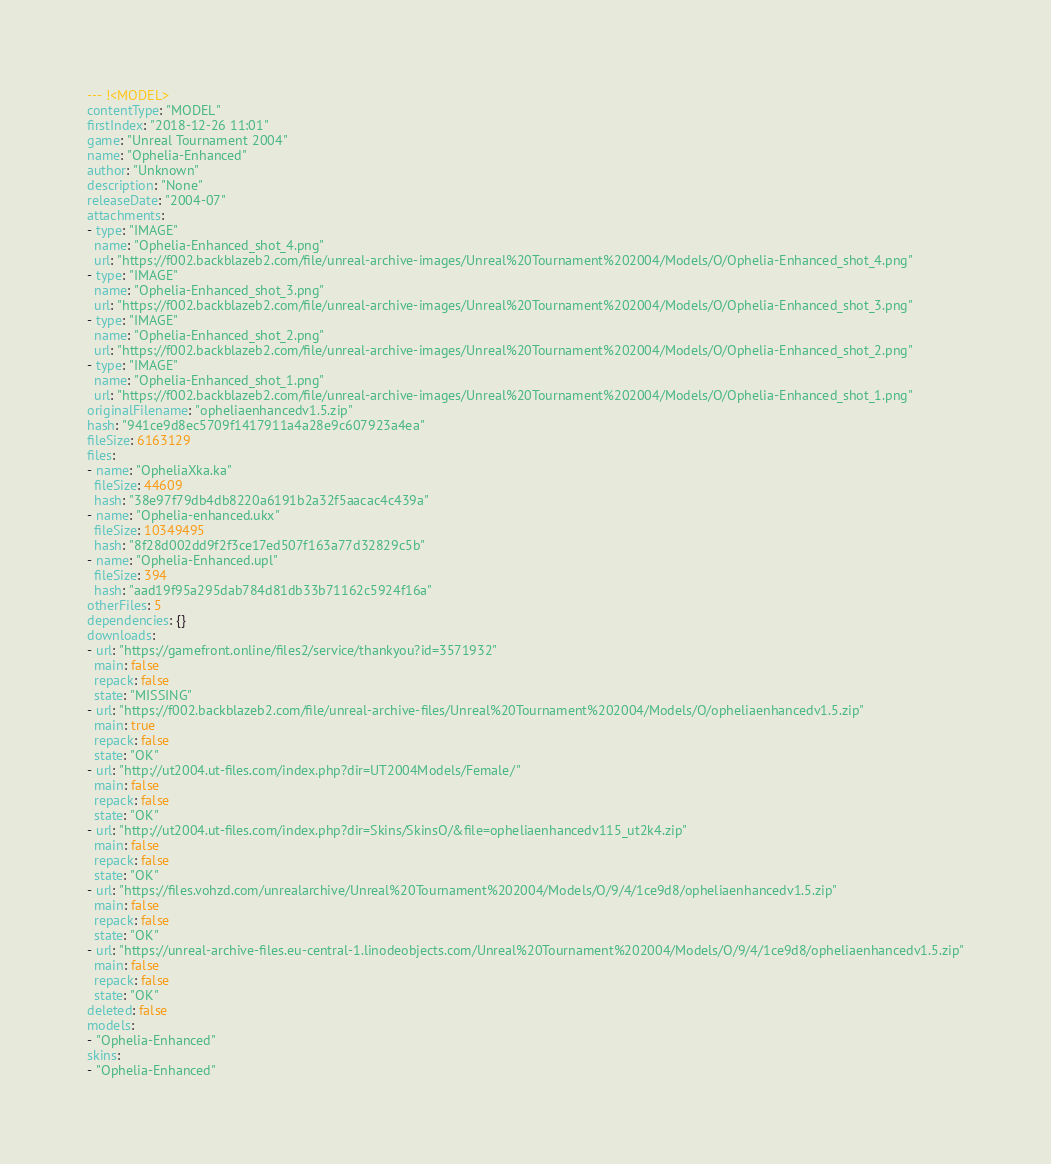Convert code to text. <code><loc_0><loc_0><loc_500><loc_500><_YAML_>--- !<MODEL>
contentType: "MODEL"
firstIndex: "2018-12-26 11:01"
game: "Unreal Tournament 2004"
name: "Ophelia-Enhanced"
author: "Unknown"
description: "None"
releaseDate: "2004-07"
attachments:
- type: "IMAGE"
  name: "Ophelia-Enhanced_shot_4.png"
  url: "https://f002.backblazeb2.com/file/unreal-archive-images/Unreal%20Tournament%202004/Models/O/Ophelia-Enhanced_shot_4.png"
- type: "IMAGE"
  name: "Ophelia-Enhanced_shot_3.png"
  url: "https://f002.backblazeb2.com/file/unreal-archive-images/Unreal%20Tournament%202004/Models/O/Ophelia-Enhanced_shot_3.png"
- type: "IMAGE"
  name: "Ophelia-Enhanced_shot_2.png"
  url: "https://f002.backblazeb2.com/file/unreal-archive-images/Unreal%20Tournament%202004/Models/O/Ophelia-Enhanced_shot_2.png"
- type: "IMAGE"
  name: "Ophelia-Enhanced_shot_1.png"
  url: "https://f002.backblazeb2.com/file/unreal-archive-images/Unreal%20Tournament%202004/Models/O/Ophelia-Enhanced_shot_1.png"
originalFilename: "opheliaenhancedv1.5.zip"
hash: "941ce9d8ec5709f1417911a4a28e9c607923a4ea"
fileSize: 6163129
files:
- name: "OpheliaXka.ka"
  fileSize: 44609
  hash: "38e97f79db4db8220a6191b2a32f5aacac4c439a"
- name: "Ophelia-enhanced.ukx"
  fileSize: 10349495
  hash: "8f28d002dd9f2f3ce17ed507f163a77d32829c5b"
- name: "Ophelia-Enhanced.upl"
  fileSize: 394
  hash: "aad19f95a295dab784d81db33b71162c5924f16a"
otherFiles: 5
dependencies: {}
downloads:
- url: "https://gamefront.online/files2/service/thankyou?id=3571932"
  main: false
  repack: false
  state: "MISSING"
- url: "https://f002.backblazeb2.com/file/unreal-archive-files/Unreal%20Tournament%202004/Models/O/opheliaenhancedv1.5.zip"
  main: true
  repack: false
  state: "OK"
- url: "http://ut2004.ut-files.com/index.php?dir=UT2004Models/Female/"
  main: false
  repack: false
  state: "OK"
- url: "http://ut2004.ut-files.com/index.php?dir=Skins/SkinsO/&file=opheliaenhancedv115_ut2k4.zip"
  main: false
  repack: false
  state: "OK"
- url: "https://files.vohzd.com/unrealarchive/Unreal%20Tournament%202004/Models/O/9/4/1ce9d8/opheliaenhancedv1.5.zip"
  main: false
  repack: false
  state: "OK"
- url: "https://unreal-archive-files.eu-central-1.linodeobjects.com/Unreal%20Tournament%202004/Models/O/9/4/1ce9d8/opheliaenhancedv1.5.zip"
  main: false
  repack: false
  state: "OK"
deleted: false
models:
- "Ophelia-Enhanced"
skins:
- "Ophelia-Enhanced"
</code> 